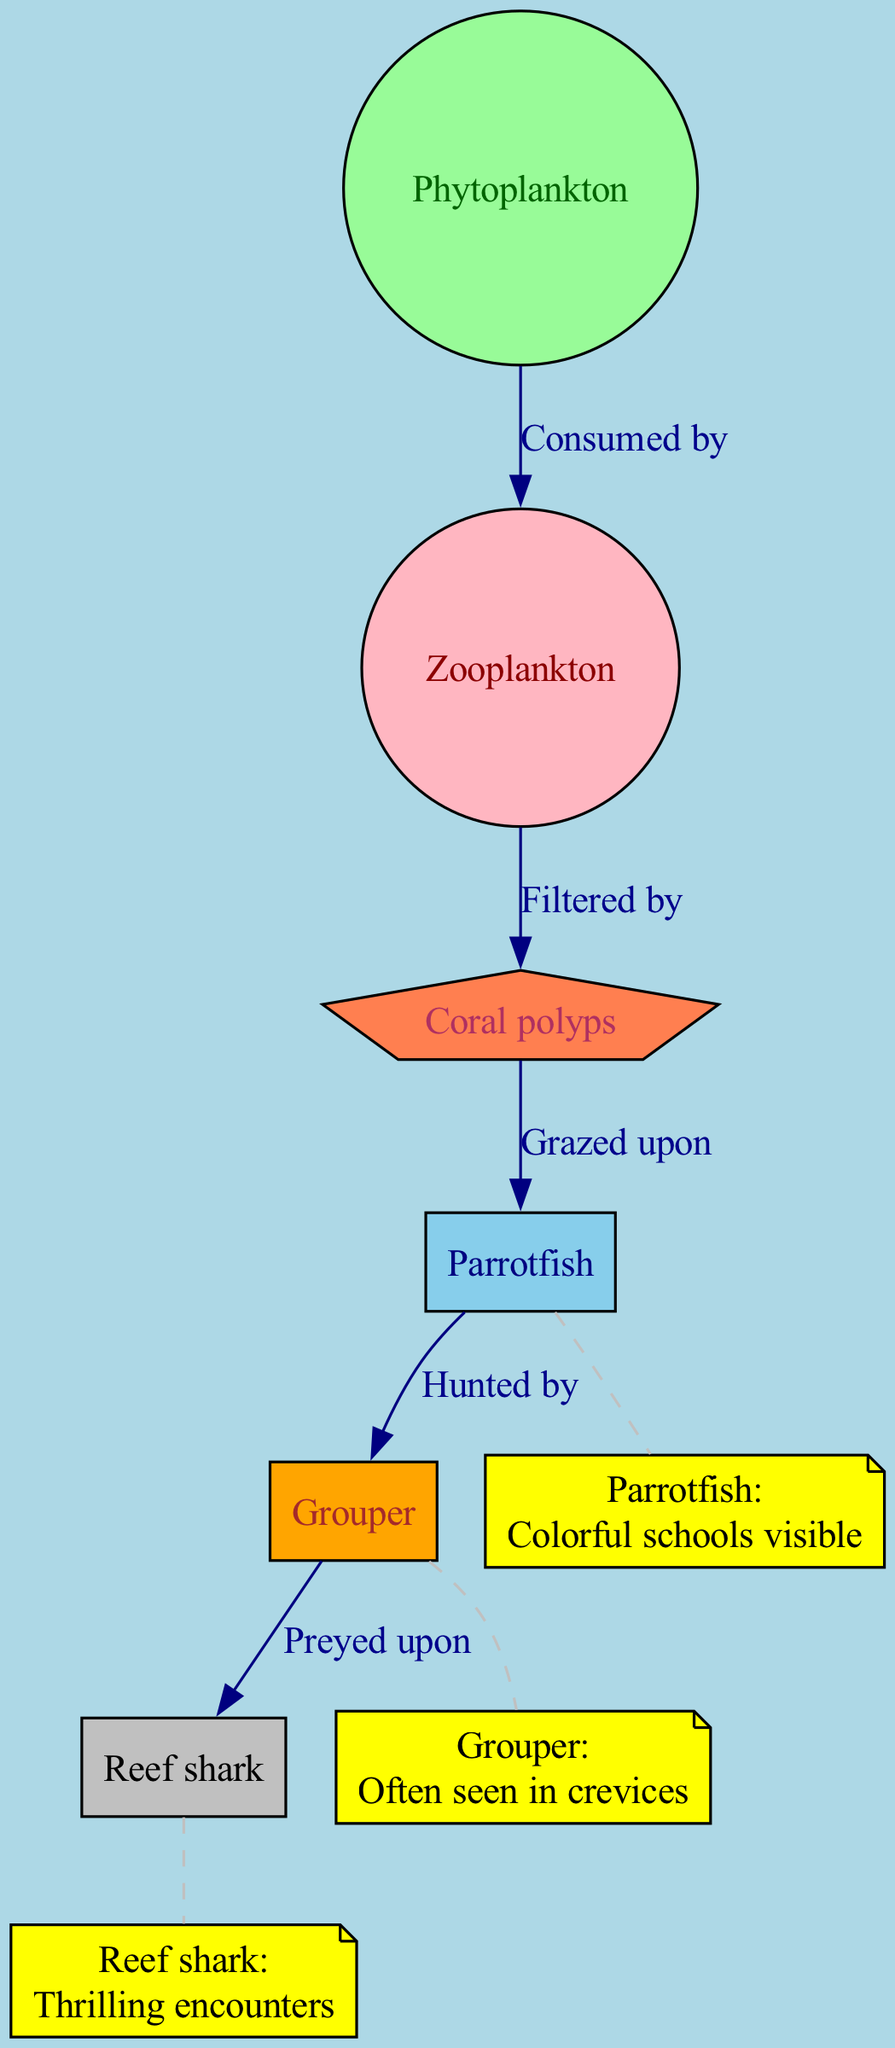What is the primary producer in this food chain? The diagram identifies "Phytoplankton" as the primary producer, as it is the first organism in the food chain and is typically responsible for photosynthesis.
Answer: Phytoplankton How many trophic levels are represented in the food chain? To determine the number of trophic levels, we count each unique organism in the food chain from producers to top predators. There are six distinct organisms: Phytoplankton, Zooplankton, Coral polyps, Parrotfish, Grouper, and Reef shark, constituting six trophic levels.
Answer: 6 Which organism is grazed upon by Parrotfish? The diagram indicates that "Coral polyps" are the organisms that are grazed upon by Parrotfish, showing a direct feeding relationship.
Answer: Coral polyps What is the relationship between Grouper and Reef shark? The diagram clearly states that "Grouper" is preyed upon by "Reef shark," indicating a predator-prey relationship between these two species.
Answer: Preyed upon How many organisms are consumed by Zooplankton? The flow of the diagram shows that "Zooplankton" is filtered by the previous trophic level, which is Phytoplankton, meaning Zooplankton has one direct organism it consumes.
Answer: 1 What type of encounters do divers have with Reef sharks? The diver interaction section mentions "Thrilling encounters" when divers observe Reef sharks, emphasizing the excitement and intensity of such experiences.
Answer: Thrilling encounters What does the Parrotfish interaction note highlight? The interaction note for Parrotfish highlights "Colorful schools visible," indicating that divers can see groups of these vibrant fish, which enhances the diving experience visually.
Answer: Colorful schools visible Which organism is found in crevices according to the diagram? The note related to Grouper mentions "Often seen in crevices," suggesting that divers can expect to spot these fish hiding in such locations during dives.
Answer: Grouper Which organism is at the top of the food chain? The diagram depicts "Reef shark" as the top organism, as it is not shown to be preyed upon by any other organism in the food chain.
Answer: Reef shark 